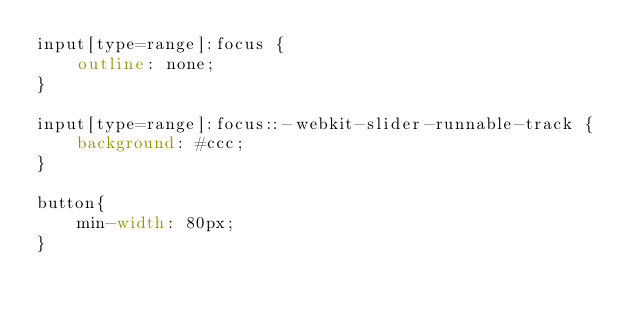Convert code to text. <code><loc_0><loc_0><loc_500><loc_500><_CSS_>input[type=range]:focus {
    outline: none;
}

input[type=range]:focus::-webkit-slider-runnable-track {
    background: #ccc;
}

button{
    min-width: 80px;
}</code> 